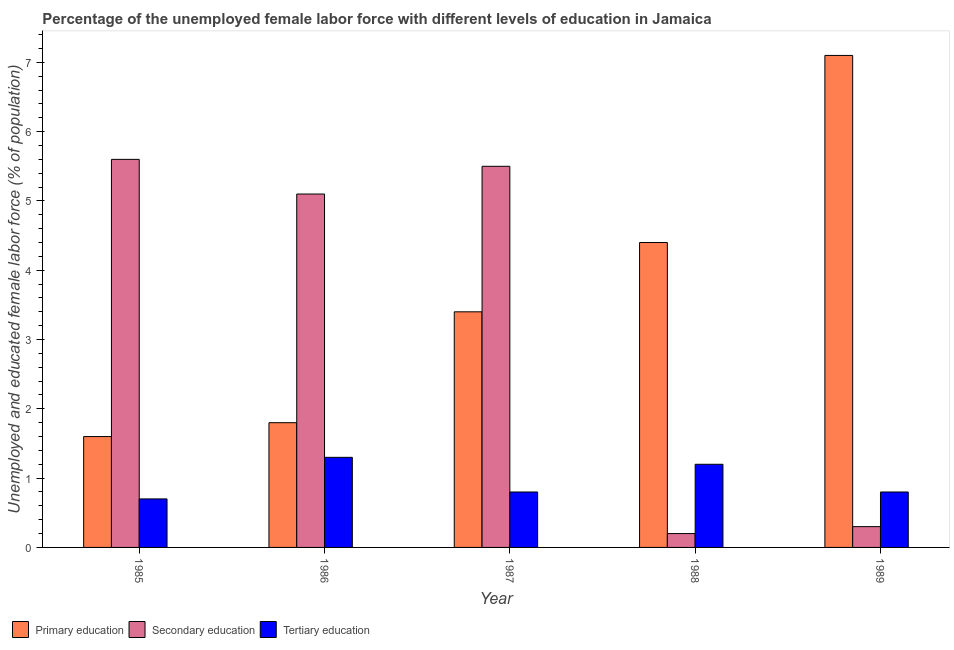How many different coloured bars are there?
Your answer should be compact. 3. How many groups of bars are there?
Provide a short and direct response. 5. How many bars are there on the 2nd tick from the right?
Provide a succinct answer. 3. In how many cases, is the number of bars for a given year not equal to the number of legend labels?
Provide a succinct answer. 0. What is the percentage of female labor force who received tertiary education in 1987?
Give a very brief answer. 0.8. Across all years, what is the maximum percentage of female labor force who received tertiary education?
Make the answer very short. 1.3. Across all years, what is the minimum percentage of female labor force who received tertiary education?
Give a very brief answer. 0.7. In which year was the percentage of female labor force who received secondary education minimum?
Ensure brevity in your answer.  1988. What is the total percentage of female labor force who received secondary education in the graph?
Provide a succinct answer. 16.7. What is the difference between the percentage of female labor force who received secondary education in 1985 and that in 1989?
Ensure brevity in your answer.  5.3. What is the difference between the percentage of female labor force who received secondary education in 1985 and the percentage of female labor force who received primary education in 1988?
Your answer should be very brief. 5.4. What is the average percentage of female labor force who received tertiary education per year?
Provide a succinct answer. 0.96. In the year 1986, what is the difference between the percentage of female labor force who received secondary education and percentage of female labor force who received tertiary education?
Your answer should be very brief. 0. In how many years, is the percentage of female labor force who received tertiary education greater than 1.8 %?
Your answer should be compact. 0. What is the ratio of the percentage of female labor force who received secondary education in 1988 to that in 1989?
Provide a succinct answer. 0.67. Is the percentage of female labor force who received tertiary education in 1985 less than that in 1989?
Keep it short and to the point. Yes. Is the difference between the percentage of female labor force who received secondary education in 1985 and 1988 greater than the difference between the percentage of female labor force who received primary education in 1985 and 1988?
Your response must be concise. No. What is the difference between the highest and the second highest percentage of female labor force who received secondary education?
Your answer should be compact. 0.1. What is the difference between the highest and the lowest percentage of female labor force who received secondary education?
Make the answer very short. 5.4. What does the 3rd bar from the left in 1988 represents?
Provide a succinct answer. Tertiary education. What does the 2nd bar from the right in 1985 represents?
Offer a terse response. Secondary education. Is it the case that in every year, the sum of the percentage of female labor force who received primary education and percentage of female labor force who received secondary education is greater than the percentage of female labor force who received tertiary education?
Provide a short and direct response. Yes. How many bars are there?
Offer a very short reply. 15. Are all the bars in the graph horizontal?
Your answer should be very brief. No. What is the difference between two consecutive major ticks on the Y-axis?
Your answer should be very brief. 1. Are the values on the major ticks of Y-axis written in scientific E-notation?
Give a very brief answer. No. Does the graph contain grids?
Give a very brief answer. No. What is the title of the graph?
Make the answer very short. Percentage of the unemployed female labor force with different levels of education in Jamaica. Does "Travel services" appear as one of the legend labels in the graph?
Provide a succinct answer. No. What is the label or title of the Y-axis?
Give a very brief answer. Unemployed and educated female labor force (% of population). What is the Unemployed and educated female labor force (% of population) of Primary education in 1985?
Provide a short and direct response. 1.6. What is the Unemployed and educated female labor force (% of population) of Secondary education in 1985?
Offer a terse response. 5.6. What is the Unemployed and educated female labor force (% of population) of Tertiary education in 1985?
Your answer should be very brief. 0.7. What is the Unemployed and educated female labor force (% of population) of Primary education in 1986?
Provide a short and direct response. 1.8. What is the Unemployed and educated female labor force (% of population) in Secondary education in 1986?
Offer a very short reply. 5.1. What is the Unemployed and educated female labor force (% of population) of Tertiary education in 1986?
Keep it short and to the point. 1.3. What is the Unemployed and educated female labor force (% of population) in Primary education in 1987?
Offer a terse response. 3.4. What is the Unemployed and educated female labor force (% of population) in Tertiary education in 1987?
Keep it short and to the point. 0.8. What is the Unemployed and educated female labor force (% of population) of Primary education in 1988?
Provide a short and direct response. 4.4. What is the Unemployed and educated female labor force (% of population) in Secondary education in 1988?
Offer a very short reply. 0.2. What is the Unemployed and educated female labor force (% of population) in Tertiary education in 1988?
Make the answer very short. 1.2. What is the Unemployed and educated female labor force (% of population) of Primary education in 1989?
Keep it short and to the point. 7.1. What is the Unemployed and educated female labor force (% of population) in Secondary education in 1989?
Make the answer very short. 0.3. What is the Unemployed and educated female labor force (% of population) of Tertiary education in 1989?
Your answer should be very brief. 0.8. Across all years, what is the maximum Unemployed and educated female labor force (% of population) in Primary education?
Offer a very short reply. 7.1. Across all years, what is the maximum Unemployed and educated female labor force (% of population) of Secondary education?
Your answer should be very brief. 5.6. Across all years, what is the maximum Unemployed and educated female labor force (% of population) in Tertiary education?
Provide a succinct answer. 1.3. Across all years, what is the minimum Unemployed and educated female labor force (% of population) in Primary education?
Your answer should be very brief. 1.6. Across all years, what is the minimum Unemployed and educated female labor force (% of population) of Secondary education?
Offer a terse response. 0.2. Across all years, what is the minimum Unemployed and educated female labor force (% of population) in Tertiary education?
Provide a short and direct response. 0.7. What is the total Unemployed and educated female labor force (% of population) in Primary education in the graph?
Offer a terse response. 18.3. What is the total Unemployed and educated female labor force (% of population) in Secondary education in the graph?
Give a very brief answer. 16.7. What is the total Unemployed and educated female labor force (% of population) in Tertiary education in the graph?
Give a very brief answer. 4.8. What is the difference between the Unemployed and educated female labor force (% of population) of Primary education in 1985 and that in 1988?
Keep it short and to the point. -2.8. What is the difference between the Unemployed and educated female labor force (% of population) of Secondary education in 1985 and that in 1989?
Offer a terse response. 5.3. What is the difference between the Unemployed and educated female labor force (% of population) in Tertiary education in 1985 and that in 1989?
Provide a short and direct response. -0.1. What is the difference between the Unemployed and educated female labor force (% of population) in Secondary education in 1986 and that in 1987?
Give a very brief answer. -0.4. What is the difference between the Unemployed and educated female labor force (% of population) of Primary education in 1986 and that in 1988?
Your response must be concise. -2.6. What is the difference between the Unemployed and educated female labor force (% of population) in Secondary education in 1986 and that in 1988?
Ensure brevity in your answer.  4.9. What is the difference between the Unemployed and educated female labor force (% of population) of Tertiary education in 1986 and that in 1989?
Your answer should be compact. 0.5. What is the difference between the Unemployed and educated female labor force (% of population) in Primary education in 1987 and that in 1989?
Offer a terse response. -3.7. What is the difference between the Unemployed and educated female labor force (% of population) in Secondary education in 1987 and that in 1989?
Give a very brief answer. 5.2. What is the difference between the Unemployed and educated female labor force (% of population) of Tertiary education in 1988 and that in 1989?
Your answer should be very brief. 0.4. What is the difference between the Unemployed and educated female labor force (% of population) in Primary education in 1985 and the Unemployed and educated female labor force (% of population) in Secondary education in 1986?
Ensure brevity in your answer.  -3.5. What is the difference between the Unemployed and educated female labor force (% of population) in Primary education in 1985 and the Unemployed and educated female labor force (% of population) in Tertiary education in 1986?
Give a very brief answer. 0.3. What is the difference between the Unemployed and educated female labor force (% of population) of Primary education in 1985 and the Unemployed and educated female labor force (% of population) of Secondary education in 1987?
Your response must be concise. -3.9. What is the difference between the Unemployed and educated female labor force (% of population) in Primary education in 1985 and the Unemployed and educated female labor force (% of population) in Secondary education in 1988?
Offer a terse response. 1.4. What is the difference between the Unemployed and educated female labor force (% of population) of Primary education in 1986 and the Unemployed and educated female labor force (% of population) of Secondary education in 1988?
Ensure brevity in your answer.  1.6. What is the difference between the Unemployed and educated female labor force (% of population) of Primary education in 1986 and the Unemployed and educated female labor force (% of population) of Secondary education in 1989?
Provide a short and direct response. 1.5. What is the difference between the Unemployed and educated female labor force (% of population) in Primary education in 1986 and the Unemployed and educated female labor force (% of population) in Tertiary education in 1989?
Keep it short and to the point. 1. What is the difference between the Unemployed and educated female labor force (% of population) in Secondary education in 1986 and the Unemployed and educated female labor force (% of population) in Tertiary education in 1989?
Keep it short and to the point. 4.3. What is the difference between the Unemployed and educated female labor force (% of population) in Primary education in 1987 and the Unemployed and educated female labor force (% of population) in Secondary education in 1988?
Make the answer very short. 3.2. What is the difference between the Unemployed and educated female labor force (% of population) in Secondary education in 1987 and the Unemployed and educated female labor force (% of population) in Tertiary education in 1988?
Your answer should be compact. 4.3. What is the difference between the Unemployed and educated female labor force (% of population) of Secondary education in 1987 and the Unemployed and educated female labor force (% of population) of Tertiary education in 1989?
Provide a short and direct response. 4.7. What is the difference between the Unemployed and educated female labor force (% of population) of Primary education in 1988 and the Unemployed and educated female labor force (% of population) of Tertiary education in 1989?
Your answer should be very brief. 3.6. What is the difference between the Unemployed and educated female labor force (% of population) in Secondary education in 1988 and the Unemployed and educated female labor force (% of population) in Tertiary education in 1989?
Keep it short and to the point. -0.6. What is the average Unemployed and educated female labor force (% of population) of Primary education per year?
Your answer should be very brief. 3.66. What is the average Unemployed and educated female labor force (% of population) in Secondary education per year?
Ensure brevity in your answer.  3.34. What is the average Unemployed and educated female labor force (% of population) of Tertiary education per year?
Your answer should be compact. 0.96. In the year 1986, what is the difference between the Unemployed and educated female labor force (% of population) of Primary education and Unemployed and educated female labor force (% of population) of Secondary education?
Ensure brevity in your answer.  -3.3. In the year 1986, what is the difference between the Unemployed and educated female labor force (% of population) of Primary education and Unemployed and educated female labor force (% of population) of Tertiary education?
Keep it short and to the point. 0.5. In the year 1986, what is the difference between the Unemployed and educated female labor force (% of population) in Secondary education and Unemployed and educated female labor force (% of population) in Tertiary education?
Ensure brevity in your answer.  3.8. In the year 1987, what is the difference between the Unemployed and educated female labor force (% of population) in Primary education and Unemployed and educated female labor force (% of population) in Secondary education?
Your response must be concise. -2.1. In the year 1987, what is the difference between the Unemployed and educated female labor force (% of population) in Primary education and Unemployed and educated female labor force (% of population) in Tertiary education?
Give a very brief answer. 2.6. In the year 1987, what is the difference between the Unemployed and educated female labor force (% of population) in Secondary education and Unemployed and educated female labor force (% of population) in Tertiary education?
Offer a very short reply. 4.7. In the year 1988, what is the difference between the Unemployed and educated female labor force (% of population) of Secondary education and Unemployed and educated female labor force (% of population) of Tertiary education?
Offer a very short reply. -1. In the year 1989, what is the difference between the Unemployed and educated female labor force (% of population) in Primary education and Unemployed and educated female labor force (% of population) in Secondary education?
Your response must be concise. 6.8. In the year 1989, what is the difference between the Unemployed and educated female labor force (% of population) in Secondary education and Unemployed and educated female labor force (% of population) in Tertiary education?
Your answer should be compact. -0.5. What is the ratio of the Unemployed and educated female labor force (% of population) of Primary education in 1985 to that in 1986?
Provide a short and direct response. 0.89. What is the ratio of the Unemployed and educated female labor force (% of population) in Secondary education in 1985 to that in 1986?
Provide a succinct answer. 1.1. What is the ratio of the Unemployed and educated female labor force (% of population) of Tertiary education in 1985 to that in 1986?
Offer a terse response. 0.54. What is the ratio of the Unemployed and educated female labor force (% of population) of Primary education in 1985 to that in 1987?
Make the answer very short. 0.47. What is the ratio of the Unemployed and educated female labor force (% of population) in Secondary education in 1985 to that in 1987?
Give a very brief answer. 1.02. What is the ratio of the Unemployed and educated female labor force (% of population) in Primary education in 1985 to that in 1988?
Provide a succinct answer. 0.36. What is the ratio of the Unemployed and educated female labor force (% of population) of Tertiary education in 1985 to that in 1988?
Provide a succinct answer. 0.58. What is the ratio of the Unemployed and educated female labor force (% of population) in Primary education in 1985 to that in 1989?
Offer a terse response. 0.23. What is the ratio of the Unemployed and educated female labor force (% of population) in Secondary education in 1985 to that in 1989?
Ensure brevity in your answer.  18.67. What is the ratio of the Unemployed and educated female labor force (% of population) in Primary education in 1986 to that in 1987?
Offer a very short reply. 0.53. What is the ratio of the Unemployed and educated female labor force (% of population) in Secondary education in 1986 to that in 1987?
Make the answer very short. 0.93. What is the ratio of the Unemployed and educated female labor force (% of population) of Tertiary education in 1986 to that in 1987?
Your answer should be compact. 1.62. What is the ratio of the Unemployed and educated female labor force (% of population) of Primary education in 1986 to that in 1988?
Offer a terse response. 0.41. What is the ratio of the Unemployed and educated female labor force (% of population) in Secondary education in 1986 to that in 1988?
Give a very brief answer. 25.5. What is the ratio of the Unemployed and educated female labor force (% of population) in Tertiary education in 1986 to that in 1988?
Offer a very short reply. 1.08. What is the ratio of the Unemployed and educated female labor force (% of population) in Primary education in 1986 to that in 1989?
Your response must be concise. 0.25. What is the ratio of the Unemployed and educated female labor force (% of population) in Secondary education in 1986 to that in 1989?
Your answer should be very brief. 17. What is the ratio of the Unemployed and educated female labor force (% of population) of Tertiary education in 1986 to that in 1989?
Keep it short and to the point. 1.62. What is the ratio of the Unemployed and educated female labor force (% of population) of Primary education in 1987 to that in 1988?
Provide a succinct answer. 0.77. What is the ratio of the Unemployed and educated female labor force (% of population) in Tertiary education in 1987 to that in 1988?
Provide a succinct answer. 0.67. What is the ratio of the Unemployed and educated female labor force (% of population) in Primary education in 1987 to that in 1989?
Make the answer very short. 0.48. What is the ratio of the Unemployed and educated female labor force (% of population) of Secondary education in 1987 to that in 1989?
Your answer should be compact. 18.33. What is the ratio of the Unemployed and educated female labor force (% of population) of Primary education in 1988 to that in 1989?
Provide a succinct answer. 0.62. What is the ratio of the Unemployed and educated female labor force (% of population) of Secondary education in 1988 to that in 1989?
Offer a very short reply. 0.67. What is the ratio of the Unemployed and educated female labor force (% of population) in Tertiary education in 1988 to that in 1989?
Offer a terse response. 1.5. What is the difference between the highest and the second highest Unemployed and educated female labor force (% of population) in Tertiary education?
Provide a short and direct response. 0.1. 